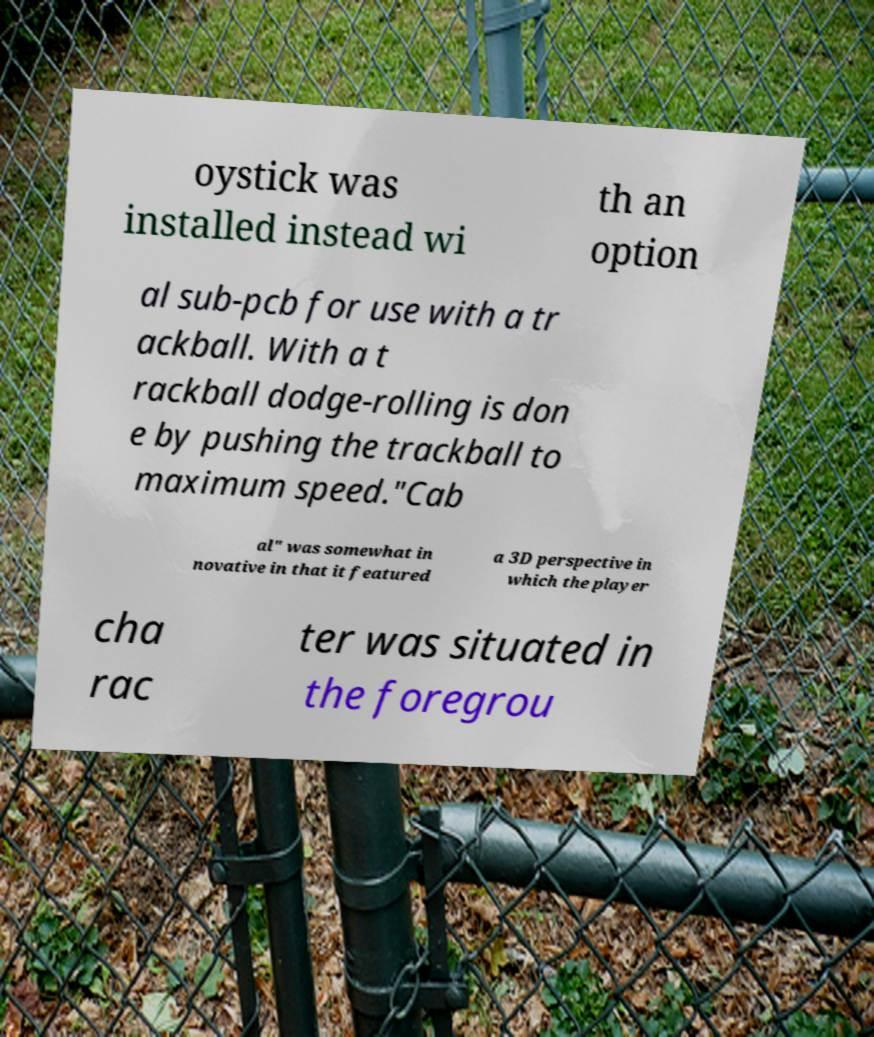For documentation purposes, I need the text within this image transcribed. Could you provide that? oystick was installed instead wi th an option al sub-pcb for use with a tr ackball. With a t rackball dodge-rolling is don e by pushing the trackball to maximum speed."Cab al" was somewhat in novative in that it featured a 3D perspective in which the player cha rac ter was situated in the foregrou 